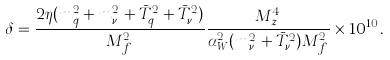<formula> <loc_0><loc_0><loc_500><loc_500>\delta = \frac { 2 \eta ( m _ { q } ^ { 2 } + m _ { \nu _ { \tau } } ^ { 2 } + \bar { T } _ { q } ^ { 2 } + \bar { T } _ { \nu _ { \tau } } ^ { 2 } ) } { M _ { f } ^ { 2 } } \frac { M _ { z } ^ { 4 } } { \alpha _ { W } ^ { 2 } ( m _ { \nu _ { \tau } } ^ { 2 } + \bar { T } _ { \nu _ { \tau } } ^ { 2 } ) M _ { f } ^ { 2 } } \times 1 0 ^ { 1 0 } .</formula> 